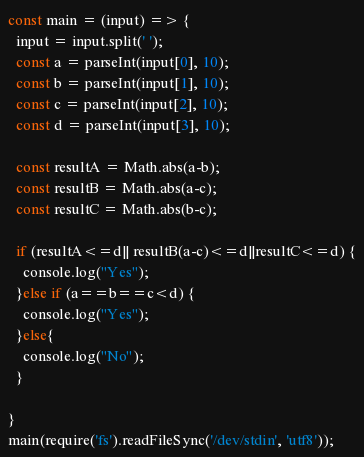<code> <loc_0><loc_0><loc_500><loc_500><_TypeScript_>const main = (input) => {
  input = input.split(' ');
  const a = parseInt(input[0], 10);
  const b = parseInt(input[1], 10);
  const c = parseInt(input[2], 10);
  const d = parseInt(input[3], 10);
  
  const resultA = Math.abs(a-b);
  const resultB = Math.abs(a-c);
  const resultC = Math.abs(b-c);
  
  if (resultA<=d|| resultB(a-c)<=d||resultC<=d) {
    console.log("Yes");
  }else if (a==b==c<d) {
    console.log("Yes");
  }else{
    console.log("No");
  }
  
}
main(require('fs').readFileSync('/dev/stdin', 'utf8'));</code> 